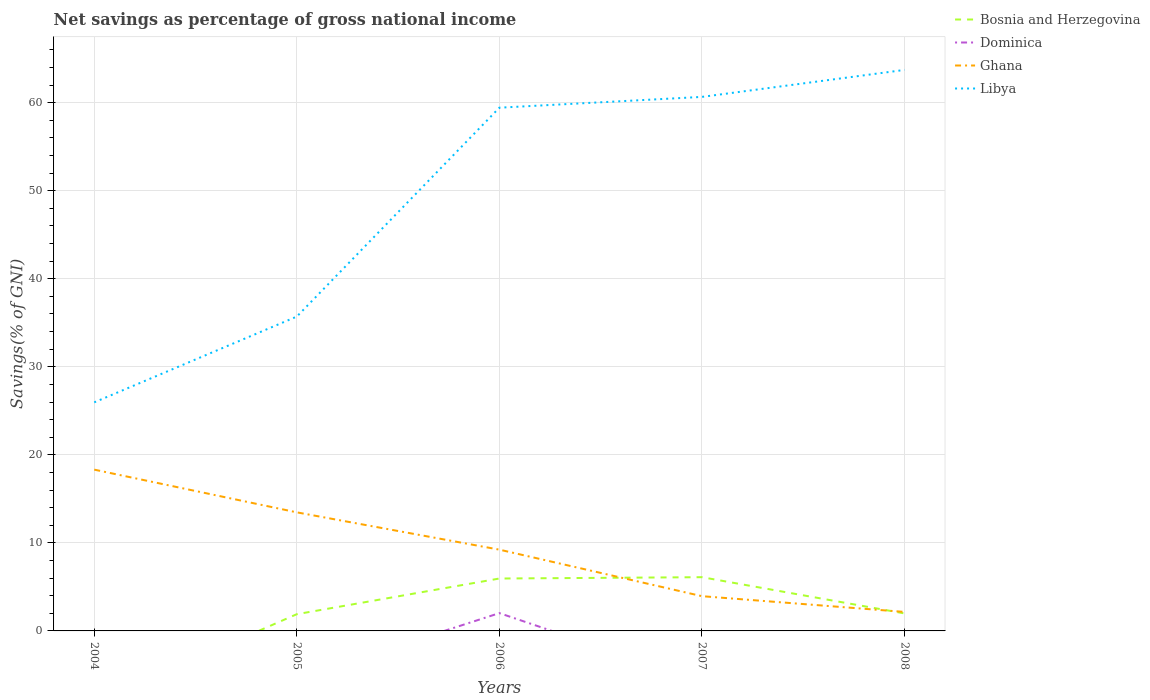What is the total total savings in Ghana in the graph?
Make the answer very short. 11.31. What is the difference between the highest and the second highest total savings in Ghana?
Offer a very short reply. 16.16. How many lines are there?
Keep it short and to the point. 4. How many years are there in the graph?
Provide a short and direct response. 5. What is the difference between two consecutive major ticks on the Y-axis?
Your answer should be compact. 10. Does the graph contain any zero values?
Keep it short and to the point. Yes. Where does the legend appear in the graph?
Provide a short and direct response. Top right. How many legend labels are there?
Provide a succinct answer. 4. How are the legend labels stacked?
Make the answer very short. Vertical. What is the title of the graph?
Ensure brevity in your answer.  Net savings as percentage of gross national income. What is the label or title of the X-axis?
Give a very brief answer. Years. What is the label or title of the Y-axis?
Offer a terse response. Savings(% of GNI). What is the Savings(% of GNI) of Bosnia and Herzegovina in 2004?
Provide a short and direct response. 0. What is the Savings(% of GNI) of Dominica in 2004?
Offer a terse response. 0. What is the Savings(% of GNI) in Ghana in 2004?
Your answer should be very brief. 18.32. What is the Savings(% of GNI) in Libya in 2004?
Your response must be concise. 25.96. What is the Savings(% of GNI) of Bosnia and Herzegovina in 2005?
Provide a succinct answer. 1.9. What is the Savings(% of GNI) in Ghana in 2005?
Provide a short and direct response. 13.47. What is the Savings(% of GNI) in Libya in 2005?
Offer a very short reply. 35.7. What is the Savings(% of GNI) in Bosnia and Herzegovina in 2006?
Ensure brevity in your answer.  5.95. What is the Savings(% of GNI) in Dominica in 2006?
Keep it short and to the point. 2.02. What is the Savings(% of GNI) in Ghana in 2006?
Your answer should be very brief. 9.23. What is the Savings(% of GNI) in Libya in 2006?
Provide a succinct answer. 59.43. What is the Savings(% of GNI) of Bosnia and Herzegovina in 2007?
Provide a short and direct response. 6.1. What is the Savings(% of GNI) in Dominica in 2007?
Provide a short and direct response. 0. What is the Savings(% of GNI) of Ghana in 2007?
Ensure brevity in your answer.  3.95. What is the Savings(% of GNI) in Libya in 2007?
Ensure brevity in your answer.  60.66. What is the Savings(% of GNI) in Bosnia and Herzegovina in 2008?
Make the answer very short. 1.99. What is the Savings(% of GNI) of Dominica in 2008?
Make the answer very short. 0. What is the Savings(% of GNI) of Ghana in 2008?
Provide a short and direct response. 2.16. What is the Savings(% of GNI) of Libya in 2008?
Your response must be concise. 63.72. Across all years, what is the maximum Savings(% of GNI) of Bosnia and Herzegovina?
Keep it short and to the point. 6.1. Across all years, what is the maximum Savings(% of GNI) in Dominica?
Your response must be concise. 2.02. Across all years, what is the maximum Savings(% of GNI) of Ghana?
Offer a very short reply. 18.32. Across all years, what is the maximum Savings(% of GNI) of Libya?
Ensure brevity in your answer.  63.72. Across all years, what is the minimum Savings(% of GNI) in Bosnia and Herzegovina?
Offer a very short reply. 0. Across all years, what is the minimum Savings(% of GNI) of Dominica?
Your answer should be very brief. 0. Across all years, what is the minimum Savings(% of GNI) in Ghana?
Offer a very short reply. 2.16. Across all years, what is the minimum Savings(% of GNI) of Libya?
Offer a terse response. 25.96. What is the total Savings(% of GNI) of Bosnia and Herzegovina in the graph?
Provide a succinct answer. 15.94. What is the total Savings(% of GNI) in Dominica in the graph?
Offer a terse response. 2.02. What is the total Savings(% of GNI) of Ghana in the graph?
Offer a very short reply. 47.12. What is the total Savings(% of GNI) in Libya in the graph?
Offer a terse response. 245.47. What is the difference between the Savings(% of GNI) of Ghana in 2004 and that in 2005?
Provide a short and direct response. 4.85. What is the difference between the Savings(% of GNI) of Libya in 2004 and that in 2005?
Offer a terse response. -9.74. What is the difference between the Savings(% of GNI) in Ghana in 2004 and that in 2006?
Ensure brevity in your answer.  9.09. What is the difference between the Savings(% of GNI) of Libya in 2004 and that in 2006?
Provide a short and direct response. -33.47. What is the difference between the Savings(% of GNI) of Ghana in 2004 and that in 2007?
Give a very brief answer. 14.37. What is the difference between the Savings(% of GNI) of Libya in 2004 and that in 2007?
Offer a very short reply. -34.69. What is the difference between the Savings(% of GNI) in Ghana in 2004 and that in 2008?
Give a very brief answer. 16.16. What is the difference between the Savings(% of GNI) of Libya in 2004 and that in 2008?
Your response must be concise. -37.76. What is the difference between the Savings(% of GNI) of Bosnia and Herzegovina in 2005 and that in 2006?
Keep it short and to the point. -4.05. What is the difference between the Savings(% of GNI) in Ghana in 2005 and that in 2006?
Ensure brevity in your answer.  4.24. What is the difference between the Savings(% of GNI) in Libya in 2005 and that in 2006?
Your answer should be very brief. -23.73. What is the difference between the Savings(% of GNI) in Bosnia and Herzegovina in 2005 and that in 2007?
Provide a succinct answer. -4.2. What is the difference between the Savings(% of GNI) in Ghana in 2005 and that in 2007?
Offer a very short reply. 9.52. What is the difference between the Savings(% of GNI) in Libya in 2005 and that in 2007?
Your response must be concise. -24.95. What is the difference between the Savings(% of GNI) in Bosnia and Herzegovina in 2005 and that in 2008?
Provide a short and direct response. -0.09. What is the difference between the Savings(% of GNI) in Ghana in 2005 and that in 2008?
Provide a short and direct response. 11.31. What is the difference between the Savings(% of GNI) of Libya in 2005 and that in 2008?
Your answer should be very brief. -28.02. What is the difference between the Savings(% of GNI) of Bosnia and Herzegovina in 2006 and that in 2007?
Make the answer very short. -0.15. What is the difference between the Savings(% of GNI) of Ghana in 2006 and that in 2007?
Make the answer very short. 5.28. What is the difference between the Savings(% of GNI) of Libya in 2006 and that in 2007?
Offer a terse response. -1.23. What is the difference between the Savings(% of GNI) in Bosnia and Herzegovina in 2006 and that in 2008?
Make the answer very short. 3.97. What is the difference between the Savings(% of GNI) in Ghana in 2006 and that in 2008?
Your response must be concise. 7.07. What is the difference between the Savings(% of GNI) of Libya in 2006 and that in 2008?
Make the answer very short. -4.29. What is the difference between the Savings(% of GNI) in Bosnia and Herzegovina in 2007 and that in 2008?
Keep it short and to the point. 4.12. What is the difference between the Savings(% of GNI) in Ghana in 2007 and that in 2008?
Provide a short and direct response. 1.79. What is the difference between the Savings(% of GNI) of Libya in 2007 and that in 2008?
Provide a short and direct response. -3.06. What is the difference between the Savings(% of GNI) of Ghana in 2004 and the Savings(% of GNI) of Libya in 2005?
Offer a very short reply. -17.38. What is the difference between the Savings(% of GNI) in Ghana in 2004 and the Savings(% of GNI) in Libya in 2006?
Make the answer very short. -41.11. What is the difference between the Savings(% of GNI) of Ghana in 2004 and the Savings(% of GNI) of Libya in 2007?
Offer a terse response. -42.34. What is the difference between the Savings(% of GNI) of Ghana in 2004 and the Savings(% of GNI) of Libya in 2008?
Offer a terse response. -45.4. What is the difference between the Savings(% of GNI) of Bosnia and Herzegovina in 2005 and the Savings(% of GNI) of Dominica in 2006?
Provide a short and direct response. -0.12. What is the difference between the Savings(% of GNI) of Bosnia and Herzegovina in 2005 and the Savings(% of GNI) of Ghana in 2006?
Give a very brief answer. -7.33. What is the difference between the Savings(% of GNI) in Bosnia and Herzegovina in 2005 and the Savings(% of GNI) in Libya in 2006?
Your answer should be very brief. -57.53. What is the difference between the Savings(% of GNI) in Ghana in 2005 and the Savings(% of GNI) in Libya in 2006?
Offer a very short reply. -45.96. What is the difference between the Savings(% of GNI) in Bosnia and Herzegovina in 2005 and the Savings(% of GNI) in Ghana in 2007?
Ensure brevity in your answer.  -2.05. What is the difference between the Savings(% of GNI) in Bosnia and Herzegovina in 2005 and the Savings(% of GNI) in Libya in 2007?
Offer a very short reply. -58.76. What is the difference between the Savings(% of GNI) of Ghana in 2005 and the Savings(% of GNI) of Libya in 2007?
Give a very brief answer. -47.19. What is the difference between the Savings(% of GNI) in Bosnia and Herzegovina in 2005 and the Savings(% of GNI) in Ghana in 2008?
Give a very brief answer. -0.26. What is the difference between the Savings(% of GNI) in Bosnia and Herzegovina in 2005 and the Savings(% of GNI) in Libya in 2008?
Keep it short and to the point. -61.82. What is the difference between the Savings(% of GNI) of Ghana in 2005 and the Savings(% of GNI) of Libya in 2008?
Your answer should be very brief. -50.25. What is the difference between the Savings(% of GNI) in Bosnia and Herzegovina in 2006 and the Savings(% of GNI) in Ghana in 2007?
Ensure brevity in your answer.  2.01. What is the difference between the Savings(% of GNI) of Bosnia and Herzegovina in 2006 and the Savings(% of GNI) of Libya in 2007?
Give a very brief answer. -54.7. What is the difference between the Savings(% of GNI) in Dominica in 2006 and the Savings(% of GNI) in Ghana in 2007?
Provide a short and direct response. -1.92. What is the difference between the Savings(% of GNI) of Dominica in 2006 and the Savings(% of GNI) of Libya in 2007?
Make the answer very short. -58.63. What is the difference between the Savings(% of GNI) in Ghana in 2006 and the Savings(% of GNI) in Libya in 2007?
Offer a very short reply. -51.43. What is the difference between the Savings(% of GNI) of Bosnia and Herzegovina in 2006 and the Savings(% of GNI) of Ghana in 2008?
Your response must be concise. 3.79. What is the difference between the Savings(% of GNI) of Bosnia and Herzegovina in 2006 and the Savings(% of GNI) of Libya in 2008?
Provide a succinct answer. -57.77. What is the difference between the Savings(% of GNI) of Dominica in 2006 and the Savings(% of GNI) of Ghana in 2008?
Your answer should be compact. -0.14. What is the difference between the Savings(% of GNI) of Dominica in 2006 and the Savings(% of GNI) of Libya in 2008?
Your response must be concise. -61.7. What is the difference between the Savings(% of GNI) in Ghana in 2006 and the Savings(% of GNI) in Libya in 2008?
Ensure brevity in your answer.  -54.49. What is the difference between the Savings(% of GNI) in Bosnia and Herzegovina in 2007 and the Savings(% of GNI) in Ghana in 2008?
Make the answer very short. 3.95. What is the difference between the Savings(% of GNI) in Bosnia and Herzegovina in 2007 and the Savings(% of GNI) in Libya in 2008?
Provide a short and direct response. -57.62. What is the difference between the Savings(% of GNI) in Ghana in 2007 and the Savings(% of GNI) in Libya in 2008?
Offer a very short reply. -59.77. What is the average Savings(% of GNI) in Bosnia and Herzegovina per year?
Keep it short and to the point. 3.19. What is the average Savings(% of GNI) in Dominica per year?
Provide a short and direct response. 0.4. What is the average Savings(% of GNI) in Ghana per year?
Your response must be concise. 9.42. What is the average Savings(% of GNI) in Libya per year?
Your response must be concise. 49.09. In the year 2004, what is the difference between the Savings(% of GNI) of Ghana and Savings(% of GNI) of Libya?
Provide a succinct answer. -7.64. In the year 2005, what is the difference between the Savings(% of GNI) in Bosnia and Herzegovina and Savings(% of GNI) in Ghana?
Ensure brevity in your answer.  -11.57. In the year 2005, what is the difference between the Savings(% of GNI) in Bosnia and Herzegovina and Savings(% of GNI) in Libya?
Ensure brevity in your answer.  -33.8. In the year 2005, what is the difference between the Savings(% of GNI) of Ghana and Savings(% of GNI) of Libya?
Offer a very short reply. -22.24. In the year 2006, what is the difference between the Savings(% of GNI) of Bosnia and Herzegovina and Savings(% of GNI) of Dominica?
Offer a very short reply. 3.93. In the year 2006, what is the difference between the Savings(% of GNI) in Bosnia and Herzegovina and Savings(% of GNI) in Ghana?
Give a very brief answer. -3.28. In the year 2006, what is the difference between the Savings(% of GNI) of Bosnia and Herzegovina and Savings(% of GNI) of Libya?
Your response must be concise. -53.48. In the year 2006, what is the difference between the Savings(% of GNI) of Dominica and Savings(% of GNI) of Ghana?
Keep it short and to the point. -7.21. In the year 2006, what is the difference between the Savings(% of GNI) in Dominica and Savings(% of GNI) in Libya?
Make the answer very short. -57.41. In the year 2006, what is the difference between the Savings(% of GNI) of Ghana and Savings(% of GNI) of Libya?
Your answer should be very brief. -50.2. In the year 2007, what is the difference between the Savings(% of GNI) of Bosnia and Herzegovina and Savings(% of GNI) of Ghana?
Provide a succinct answer. 2.16. In the year 2007, what is the difference between the Savings(% of GNI) in Bosnia and Herzegovina and Savings(% of GNI) in Libya?
Give a very brief answer. -54.55. In the year 2007, what is the difference between the Savings(% of GNI) of Ghana and Savings(% of GNI) of Libya?
Give a very brief answer. -56.71. In the year 2008, what is the difference between the Savings(% of GNI) of Bosnia and Herzegovina and Savings(% of GNI) of Ghana?
Your response must be concise. -0.17. In the year 2008, what is the difference between the Savings(% of GNI) in Bosnia and Herzegovina and Savings(% of GNI) in Libya?
Give a very brief answer. -61.73. In the year 2008, what is the difference between the Savings(% of GNI) of Ghana and Savings(% of GNI) of Libya?
Keep it short and to the point. -61.56. What is the ratio of the Savings(% of GNI) in Ghana in 2004 to that in 2005?
Give a very brief answer. 1.36. What is the ratio of the Savings(% of GNI) of Libya in 2004 to that in 2005?
Make the answer very short. 0.73. What is the ratio of the Savings(% of GNI) in Ghana in 2004 to that in 2006?
Your response must be concise. 1.98. What is the ratio of the Savings(% of GNI) of Libya in 2004 to that in 2006?
Give a very brief answer. 0.44. What is the ratio of the Savings(% of GNI) in Ghana in 2004 to that in 2007?
Provide a short and direct response. 4.64. What is the ratio of the Savings(% of GNI) of Libya in 2004 to that in 2007?
Offer a terse response. 0.43. What is the ratio of the Savings(% of GNI) in Ghana in 2004 to that in 2008?
Keep it short and to the point. 8.49. What is the ratio of the Savings(% of GNI) in Libya in 2004 to that in 2008?
Give a very brief answer. 0.41. What is the ratio of the Savings(% of GNI) in Bosnia and Herzegovina in 2005 to that in 2006?
Give a very brief answer. 0.32. What is the ratio of the Savings(% of GNI) of Ghana in 2005 to that in 2006?
Offer a terse response. 1.46. What is the ratio of the Savings(% of GNI) of Libya in 2005 to that in 2006?
Your answer should be compact. 0.6. What is the ratio of the Savings(% of GNI) of Bosnia and Herzegovina in 2005 to that in 2007?
Offer a terse response. 0.31. What is the ratio of the Savings(% of GNI) in Ghana in 2005 to that in 2007?
Ensure brevity in your answer.  3.41. What is the ratio of the Savings(% of GNI) in Libya in 2005 to that in 2007?
Your answer should be compact. 0.59. What is the ratio of the Savings(% of GNI) in Bosnia and Herzegovina in 2005 to that in 2008?
Give a very brief answer. 0.96. What is the ratio of the Savings(% of GNI) in Ghana in 2005 to that in 2008?
Give a very brief answer. 6.24. What is the ratio of the Savings(% of GNI) in Libya in 2005 to that in 2008?
Make the answer very short. 0.56. What is the ratio of the Savings(% of GNI) of Bosnia and Herzegovina in 2006 to that in 2007?
Provide a short and direct response. 0.98. What is the ratio of the Savings(% of GNI) in Ghana in 2006 to that in 2007?
Offer a terse response. 2.34. What is the ratio of the Savings(% of GNI) of Libya in 2006 to that in 2007?
Make the answer very short. 0.98. What is the ratio of the Savings(% of GNI) in Bosnia and Herzegovina in 2006 to that in 2008?
Your answer should be compact. 3. What is the ratio of the Savings(% of GNI) in Ghana in 2006 to that in 2008?
Provide a succinct answer. 4.28. What is the ratio of the Savings(% of GNI) of Libya in 2006 to that in 2008?
Make the answer very short. 0.93. What is the ratio of the Savings(% of GNI) of Bosnia and Herzegovina in 2007 to that in 2008?
Keep it short and to the point. 3.07. What is the ratio of the Savings(% of GNI) of Ghana in 2007 to that in 2008?
Give a very brief answer. 1.83. What is the ratio of the Savings(% of GNI) of Libya in 2007 to that in 2008?
Give a very brief answer. 0.95. What is the difference between the highest and the second highest Savings(% of GNI) of Bosnia and Herzegovina?
Give a very brief answer. 0.15. What is the difference between the highest and the second highest Savings(% of GNI) of Ghana?
Offer a very short reply. 4.85. What is the difference between the highest and the second highest Savings(% of GNI) in Libya?
Give a very brief answer. 3.06. What is the difference between the highest and the lowest Savings(% of GNI) in Bosnia and Herzegovina?
Provide a succinct answer. 6.1. What is the difference between the highest and the lowest Savings(% of GNI) of Dominica?
Provide a short and direct response. 2.02. What is the difference between the highest and the lowest Savings(% of GNI) of Ghana?
Provide a succinct answer. 16.16. What is the difference between the highest and the lowest Savings(% of GNI) of Libya?
Provide a short and direct response. 37.76. 